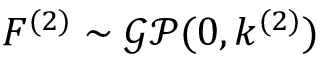Convert formula to latex. <formula><loc_0><loc_0><loc_500><loc_500>F ^ { ( 2 ) } \sim \mathcal { G P } ( 0 , k ^ { ( 2 ) } )</formula> 